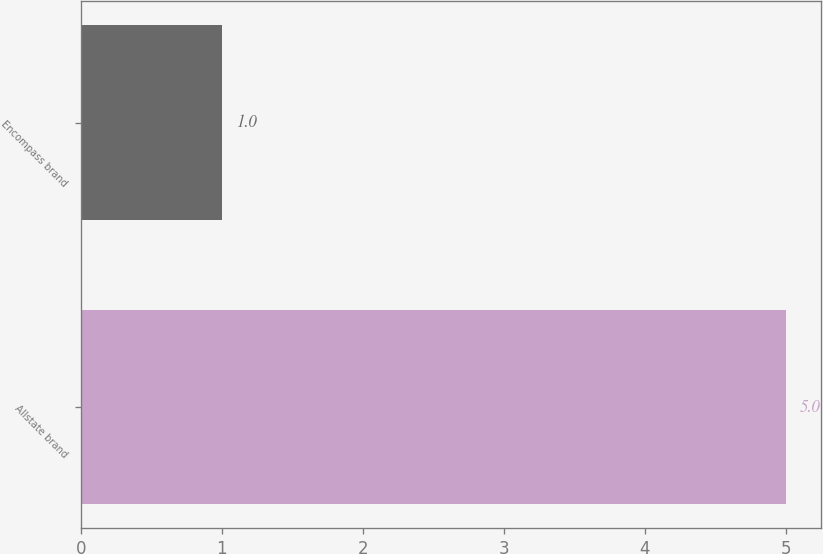Convert chart to OTSL. <chart><loc_0><loc_0><loc_500><loc_500><bar_chart><fcel>Allstate brand<fcel>Encompass brand<nl><fcel>5<fcel>1<nl></chart> 